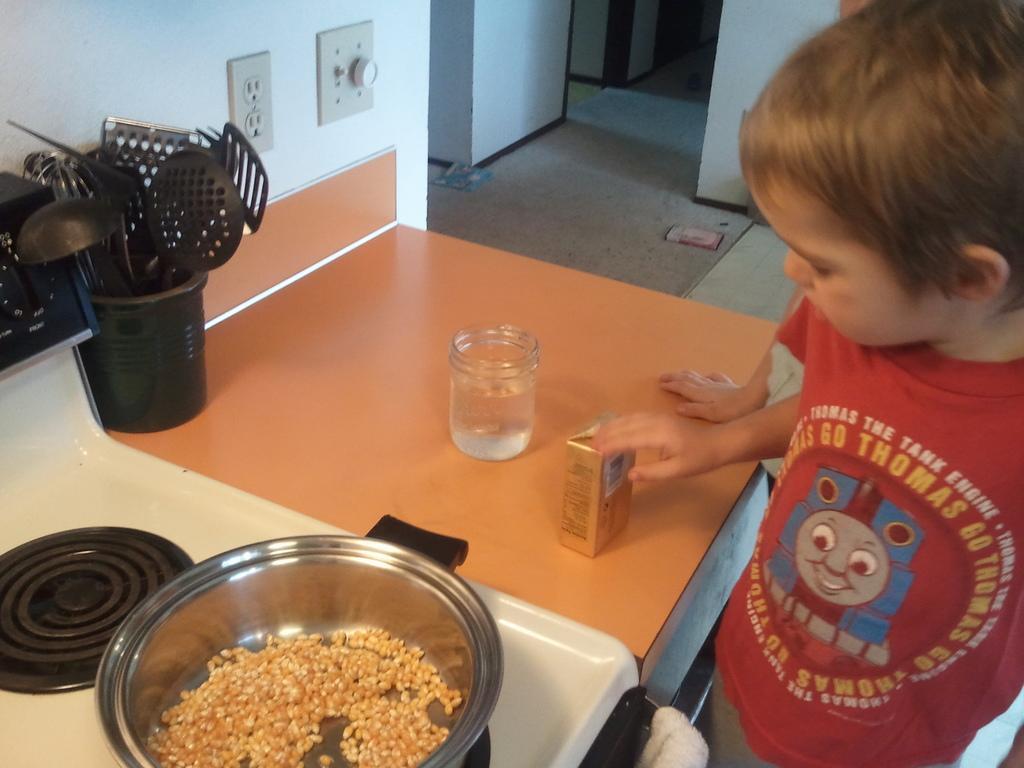How would you summarize this image in a sentence or two? In the foreground of this image, on the right, there is a boy and it seems like there is a person behind him. On the left, there is a vessel on the stove. We can also see few spatulas and spoons in a basket, a container and a box on the table. At the top, there are walls, floor, and socket and regulator on the wall. 